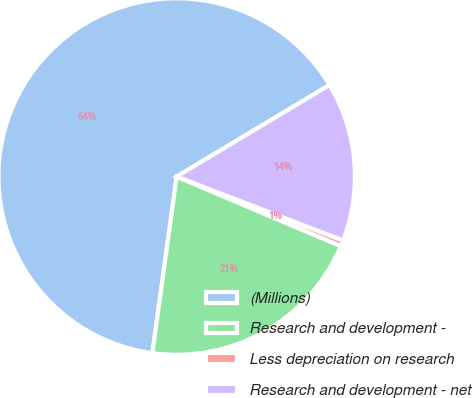<chart> <loc_0><loc_0><loc_500><loc_500><pie_chart><fcel>(Millions)<fcel>Research and development -<fcel>Less depreciation on research<fcel>Research and development - net<nl><fcel>64.23%<fcel>20.8%<fcel>0.54%<fcel>14.43%<nl></chart> 